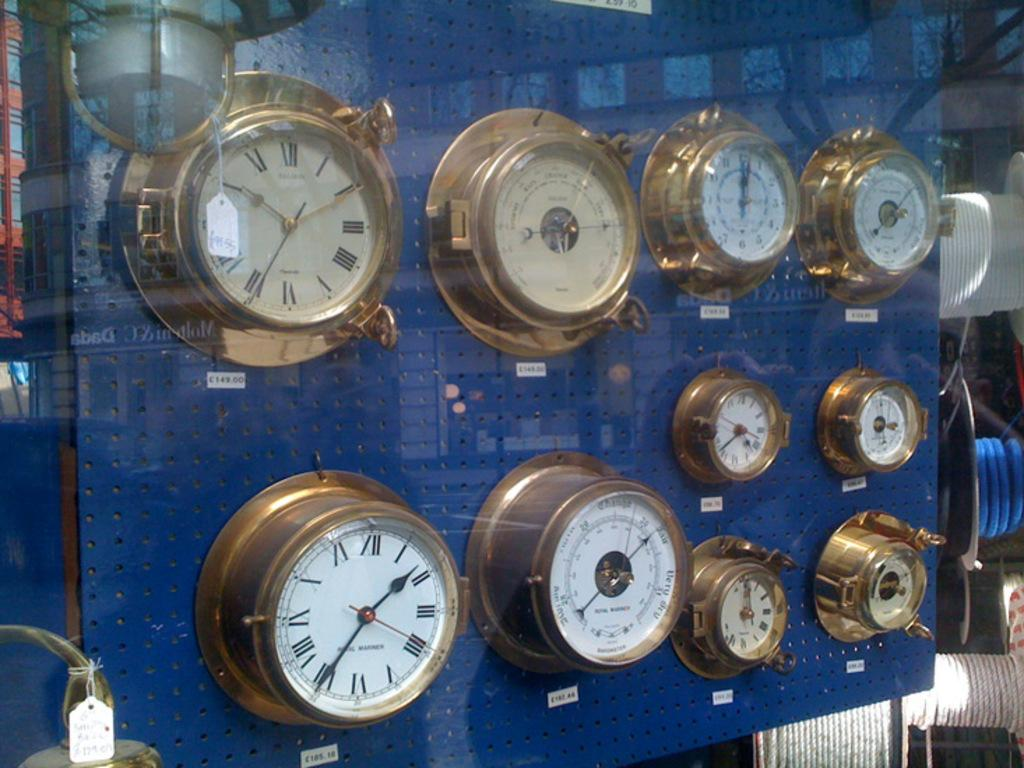<image>
Relay a brief, clear account of the picture shown. The upper left clock in this display is labeled with a small white tag that begins with the letter C. 